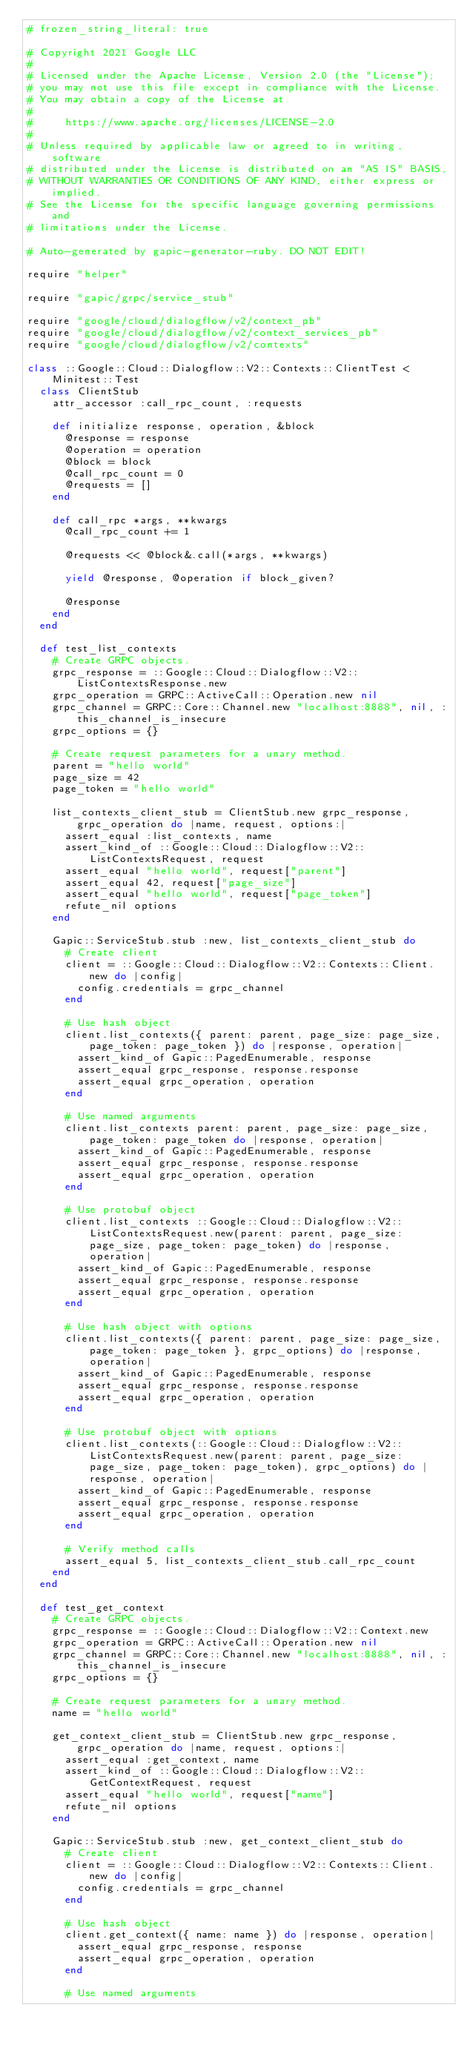<code> <loc_0><loc_0><loc_500><loc_500><_Ruby_># frozen_string_literal: true

# Copyright 2021 Google LLC
#
# Licensed under the Apache License, Version 2.0 (the "License");
# you may not use this file except in compliance with the License.
# You may obtain a copy of the License at
#
#     https://www.apache.org/licenses/LICENSE-2.0
#
# Unless required by applicable law or agreed to in writing, software
# distributed under the License is distributed on an "AS IS" BASIS,
# WITHOUT WARRANTIES OR CONDITIONS OF ANY KIND, either express or implied.
# See the License for the specific language governing permissions and
# limitations under the License.

# Auto-generated by gapic-generator-ruby. DO NOT EDIT!

require "helper"

require "gapic/grpc/service_stub"

require "google/cloud/dialogflow/v2/context_pb"
require "google/cloud/dialogflow/v2/context_services_pb"
require "google/cloud/dialogflow/v2/contexts"

class ::Google::Cloud::Dialogflow::V2::Contexts::ClientTest < Minitest::Test
  class ClientStub
    attr_accessor :call_rpc_count, :requests

    def initialize response, operation, &block
      @response = response
      @operation = operation
      @block = block
      @call_rpc_count = 0
      @requests = []
    end

    def call_rpc *args, **kwargs
      @call_rpc_count += 1

      @requests << @block&.call(*args, **kwargs)

      yield @response, @operation if block_given?

      @response
    end
  end

  def test_list_contexts
    # Create GRPC objects.
    grpc_response = ::Google::Cloud::Dialogflow::V2::ListContextsResponse.new
    grpc_operation = GRPC::ActiveCall::Operation.new nil
    grpc_channel = GRPC::Core::Channel.new "localhost:8888", nil, :this_channel_is_insecure
    grpc_options = {}

    # Create request parameters for a unary method.
    parent = "hello world"
    page_size = 42
    page_token = "hello world"

    list_contexts_client_stub = ClientStub.new grpc_response, grpc_operation do |name, request, options:|
      assert_equal :list_contexts, name
      assert_kind_of ::Google::Cloud::Dialogflow::V2::ListContextsRequest, request
      assert_equal "hello world", request["parent"]
      assert_equal 42, request["page_size"]
      assert_equal "hello world", request["page_token"]
      refute_nil options
    end

    Gapic::ServiceStub.stub :new, list_contexts_client_stub do
      # Create client
      client = ::Google::Cloud::Dialogflow::V2::Contexts::Client.new do |config|
        config.credentials = grpc_channel
      end

      # Use hash object
      client.list_contexts({ parent: parent, page_size: page_size, page_token: page_token }) do |response, operation|
        assert_kind_of Gapic::PagedEnumerable, response
        assert_equal grpc_response, response.response
        assert_equal grpc_operation, operation
      end

      # Use named arguments
      client.list_contexts parent: parent, page_size: page_size, page_token: page_token do |response, operation|
        assert_kind_of Gapic::PagedEnumerable, response
        assert_equal grpc_response, response.response
        assert_equal grpc_operation, operation
      end

      # Use protobuf object
      client.list_contexts ::Google::Cloud::Dialogflow::V2::ListContextsRequest.new(parent: parent, page_size: page_size, page_token: page_token) do |response, operation|
        assert_kind_of Gapic::PagedEnumerable, response
        assert_equal grpc_response, response.response
        assert_equal grpc_operation, operation
      end

      # Use hash object with options
      client.list_contexts({ parent: parent, page_size: page_size, page_token: page_token }, grpc_options) do |response, operation|
        assert_kind_of Gapic::PagedEnumerable, response
        assert_equal grpc_response, response.response
        assert_equal grpc_operation, operation
      end

      # Use protobuf object with options
      client.list_contexts(::Google::Cloud::Dialogflow::V2::ListContextsRequest.new(parent: parent, page_size: page_size, page_token: page_token), grpc_options) do |response, operation|
        assert_kind_of Gapic::PagedEnumerable, response
        assert_equal grpc_response, response.response
        assert_equal grpc_operation, operation
      end

      # Verify method calls
      assert_equal 5, list_contexts_client_stub.call_rpc_count
    end
  end

  def test_get_context
    # Create GRPC objects.
    grpc_response = ::Google::Cloud::Dialogflow::V2::Context.new
    grpc_operation = GRPC::ActiveCall::Operation.new nil
    grpc_channel = GRPC::Core::Channel.new "localhost:8888", nil, :this_channel_is_insecure
    grpc_options = {}

    # Create request parameters for a unary method.
    name = "hello world"

    get_context_client_stub = ClientStub.new grpc_response, grpc_operation do |name, request, options:|
      assert_equal :get_context, name
      assert_kind_of ::Google::Cloud::Dialogflow::V2::GetContextRequest, request
      assert_equal "hello world", request["name"]
      refute_nil options
    end

    Gapic::ServiceStub.stub :new, get_context_client_stub do
      # Create client
      client = ::Google::Cloud::Dialogflow::V2::Contexts::Client.new do |config|
        config.credentials = grpc_channel
      end

      # Use hash object
      client.get_context({ name: name }) do |response, operation|
        assert_equal grpc_response, response
        assert_equal grpc_operation, operation
      end

      # Use named arguments</code> 